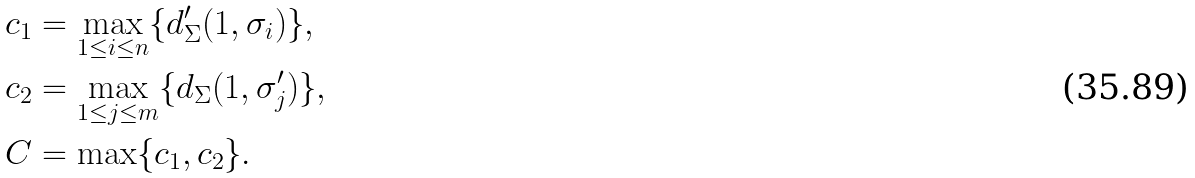<formula> <loc_0><loc_0><loc_500><loc_500>c _ { 1 } & = \max _ { 1 \leq i \leq n } \{ d _ { \Sigma } ^ { \prime } ( 1 , \sigma _ { i } ) \} , \\ c _ { 2 } & = \max _ { 1 \leq j \leq m } \{ d _ { \Sigma } ( 1 , \sigma _ { j } ^ { \prime } ) \} , \\ C & = \max \{ c _ { 1 } , c _ { 2 } \} .</formula> 